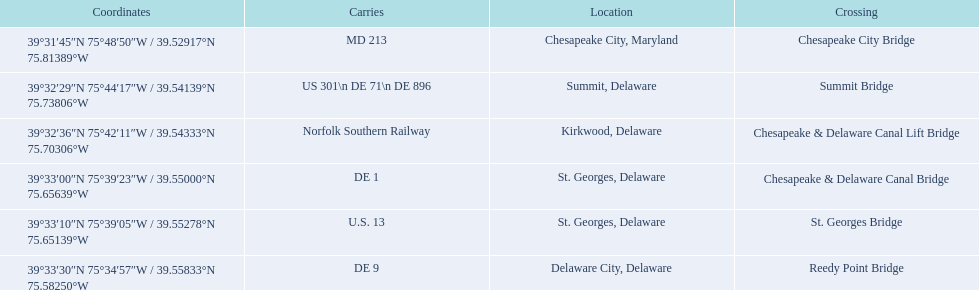What are the names of the major crossings for the chesapeake and delaware canal? Chesapeake City Bridge, Summit Bridge, Chesapeake & Delaware Canal Lift Bridge, Chesapeake & Delaware Canal Bridge, St. Georges Bridge, Reedy Point Bridge. What routes are carried by these crossings? MD 213, US 301\n DE 71\n DE 896, Norfolk Southern Railway, DE 1, U.S. 13, DE 9. Which of those routes is comprised of more than one route? US 301\n DE 71\n DE 896. Which crossing carries those routes? Summit Bridge. 